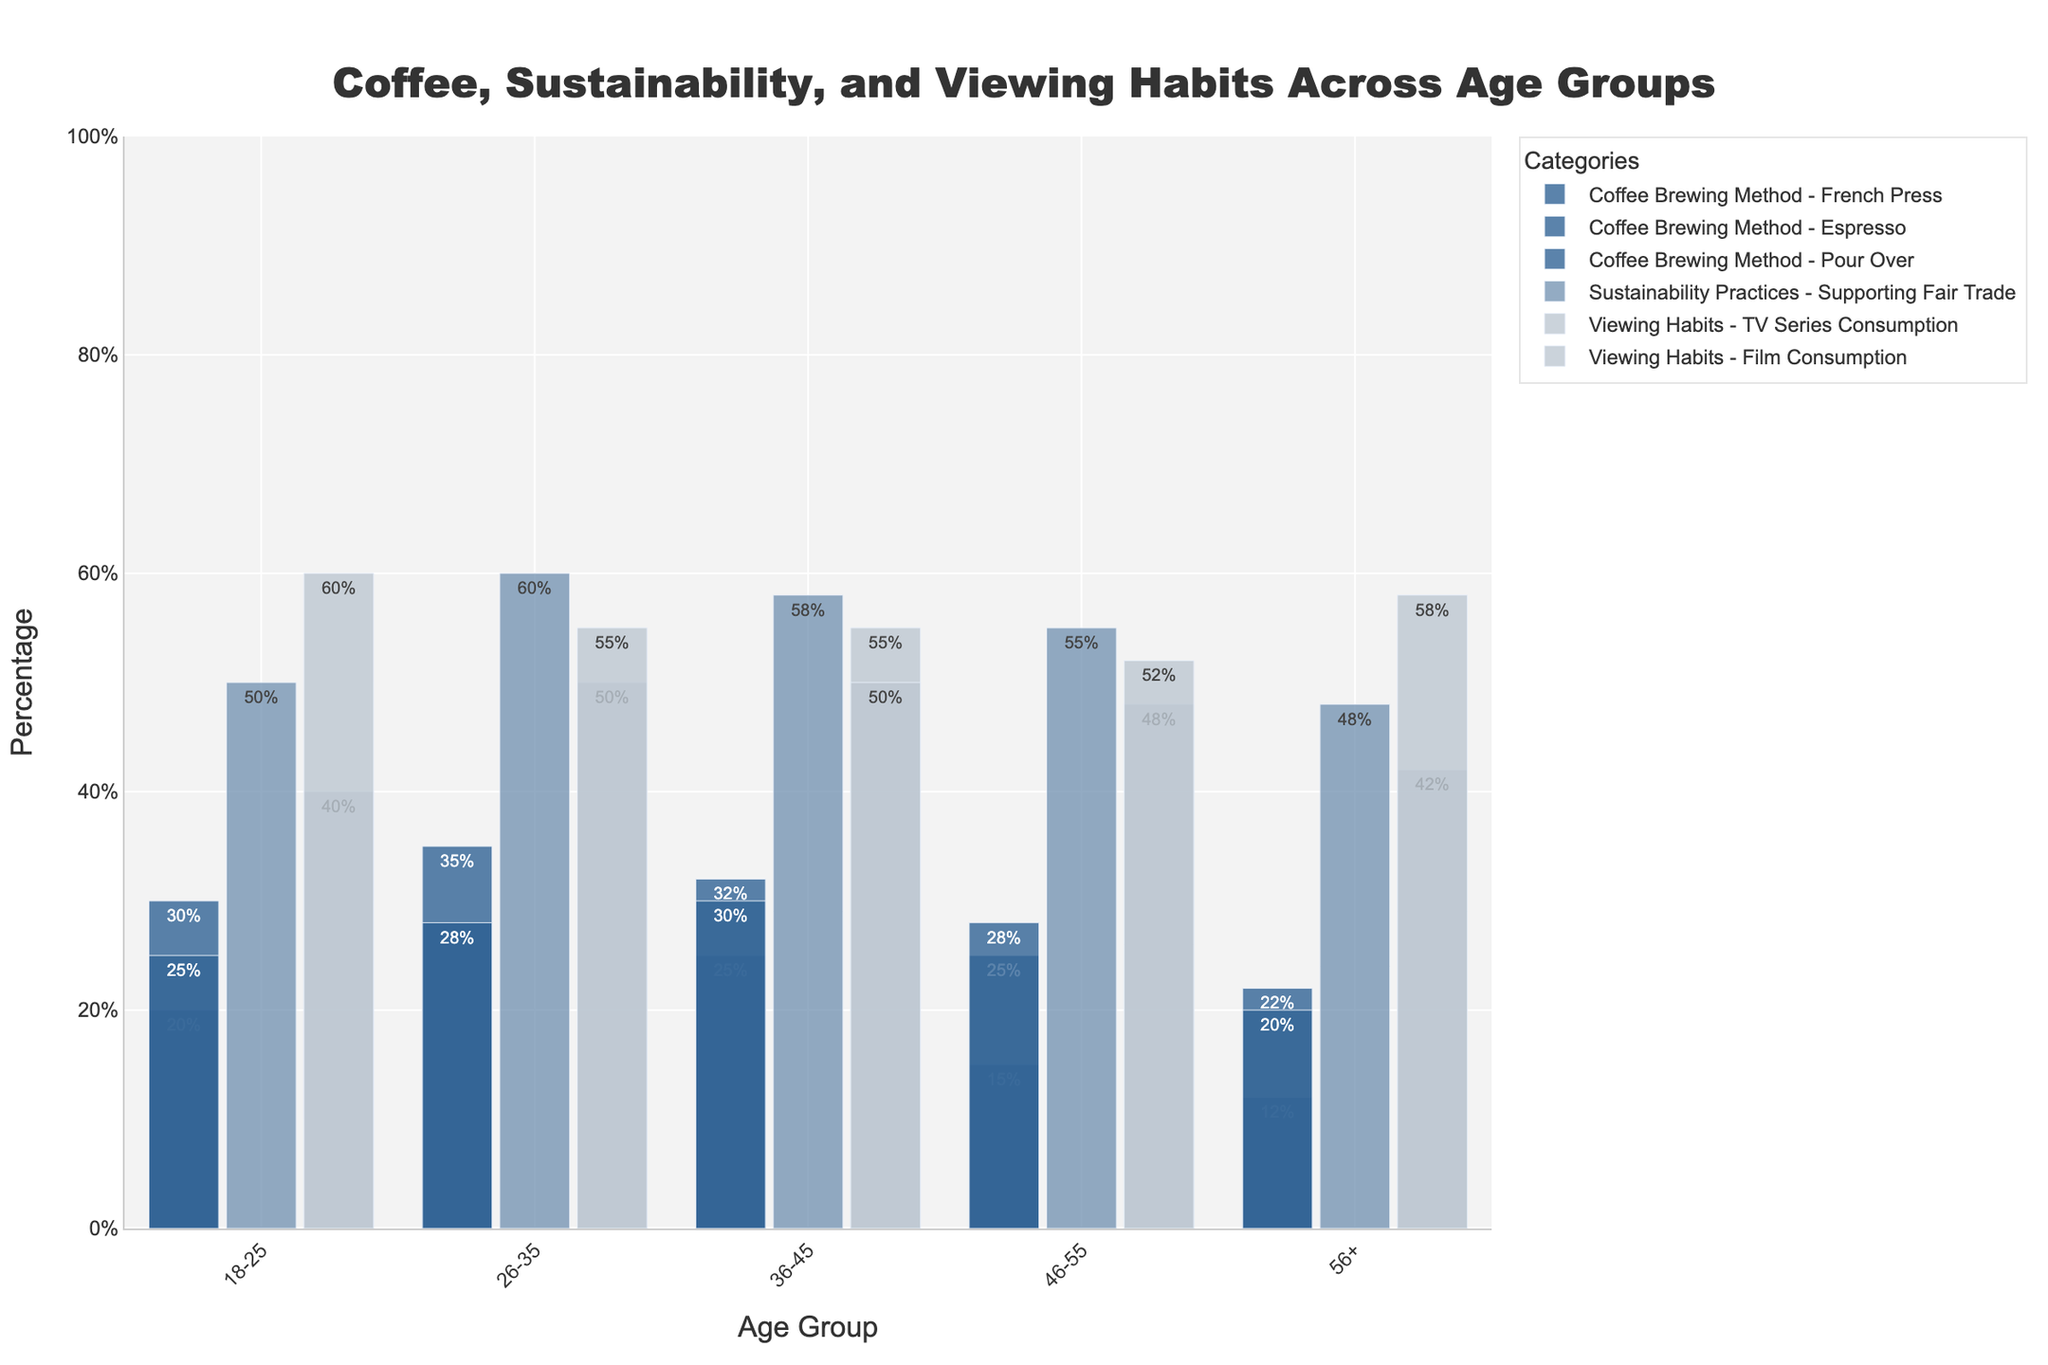What percentage of the 26-35 age group prefers Espresso compared to French Press? To find the percentage difference, look at the bars labeled Espresso and French Press for the age group 26-35. Espresso is 35% and French Press is 28%. Subtract the two percentages: 35% - 28% = 7%.
Answer: 7% Which age group has the highest preference for Pour Over method? Examine all the bars representing Pour Over across different age groups. The 36-45 group shows a preference of 30%, which is the highest among all age groups.
Answer: 36-45 What is the overall trend in preference for Film Consumption as age increases? Observing the bars for Film Consumption across all age groups, the percentages mostly rise from 60% (18-25) to 58% (56+), suggesting an increase in film consumption with age, except for a slight dip in the 26-35 group.
Answer: Increases with age How many categories show a higher percentage for the 18-25 age group compared to the 56+ age group? Compare the bars across all categories for 18-25 and 56+ age groups. Espresso (30% vs 22%), French Press (20% vs 12%), and TV Series Consumption (40% vs 42%) show higher, amounting to three categories.
Answer: 3 categories What is the combined support for Fair Trade among the 26-35 and 36-45 age groups? Add the percentages for Fair Trade support in the 26-35 (60%) and 36-45 (58%) groups: 60% + 58% = 118%.
Answer: 118% Which age group prefers TV Series Consumption the most and by what percentage? Identify the highest percentage bar for TV Series Consumption, which is 36-45 at 55%.
Answer: 36-45, 55% Between which two coffee brewing methods is the preference closest for the 46-55 age group? Compare the bars for all coffee brewing methods in the 46-55 age group. Pour Over (28%) and Espresso (25%) are the closest, with just a 3% difference.
Answer: Pour Over and Espresso What is the preference difference for Fair Trade Support between the highest and lowest age groups? Find the highest and lowest percentages for Fair Trade, which are 60% (26-35) and 48% (56+). The difference is 60% - 48% = 12%.
Answer: 12% Which two categories display an increase in percentage as the age group progresses from 18-25 to 56+? Look for categories whose bars show an increasing trend across age groups. Film Consumption and Espresso both show this trend.
Answer: Film Consumption and Espresso What is the percentage difference in TV Series Consumption between the age group 36-45 and 56+? Compare the percentages for TV Series Consumption in these age groups: 55% (36-45) - 42% (56+) = 13%.
Answer: 13% 